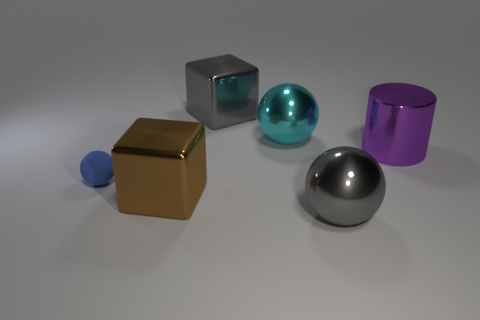Add 2 large cyan matte spheres. How many objects exist? 8 Subtract all blocks. How many objects are left? 4 Add 4 big objects. How many big objects exist? 9 Subtract 0 green spheres. How many objects are left? 6 Subtract all large purple cylinders. Subtract all gray blocks. How many objects are left? 4 Add 6 large cyan metal things. How many large cyan metal things are left? 7 